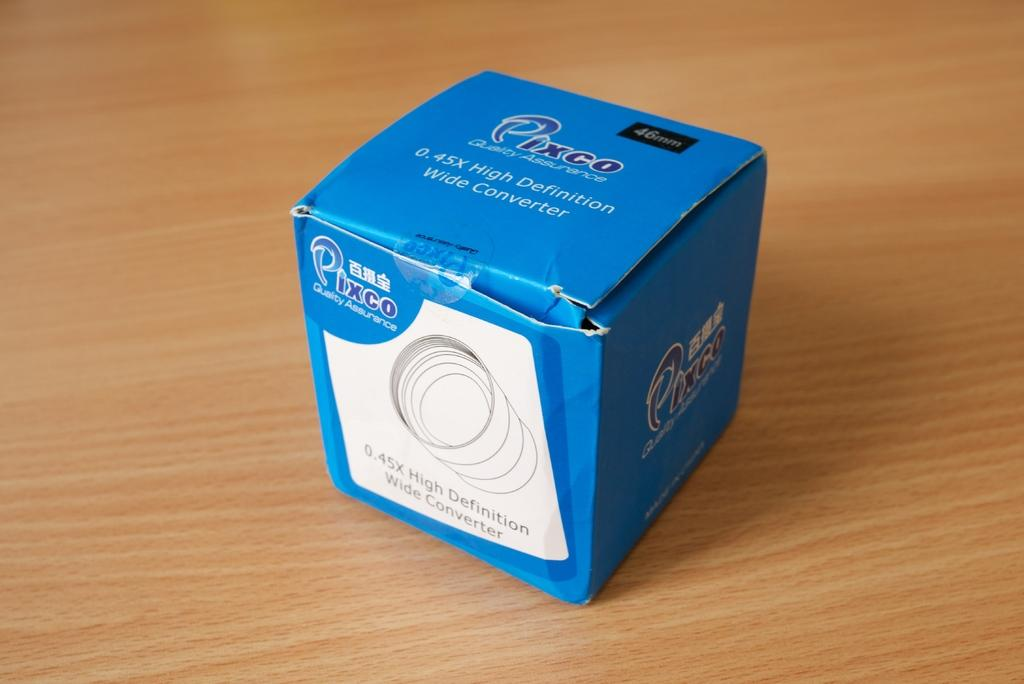<image>
Offer a succinct explanation of the picture presented. A blue box with the brand name Pixco sits on a wooden surface. 